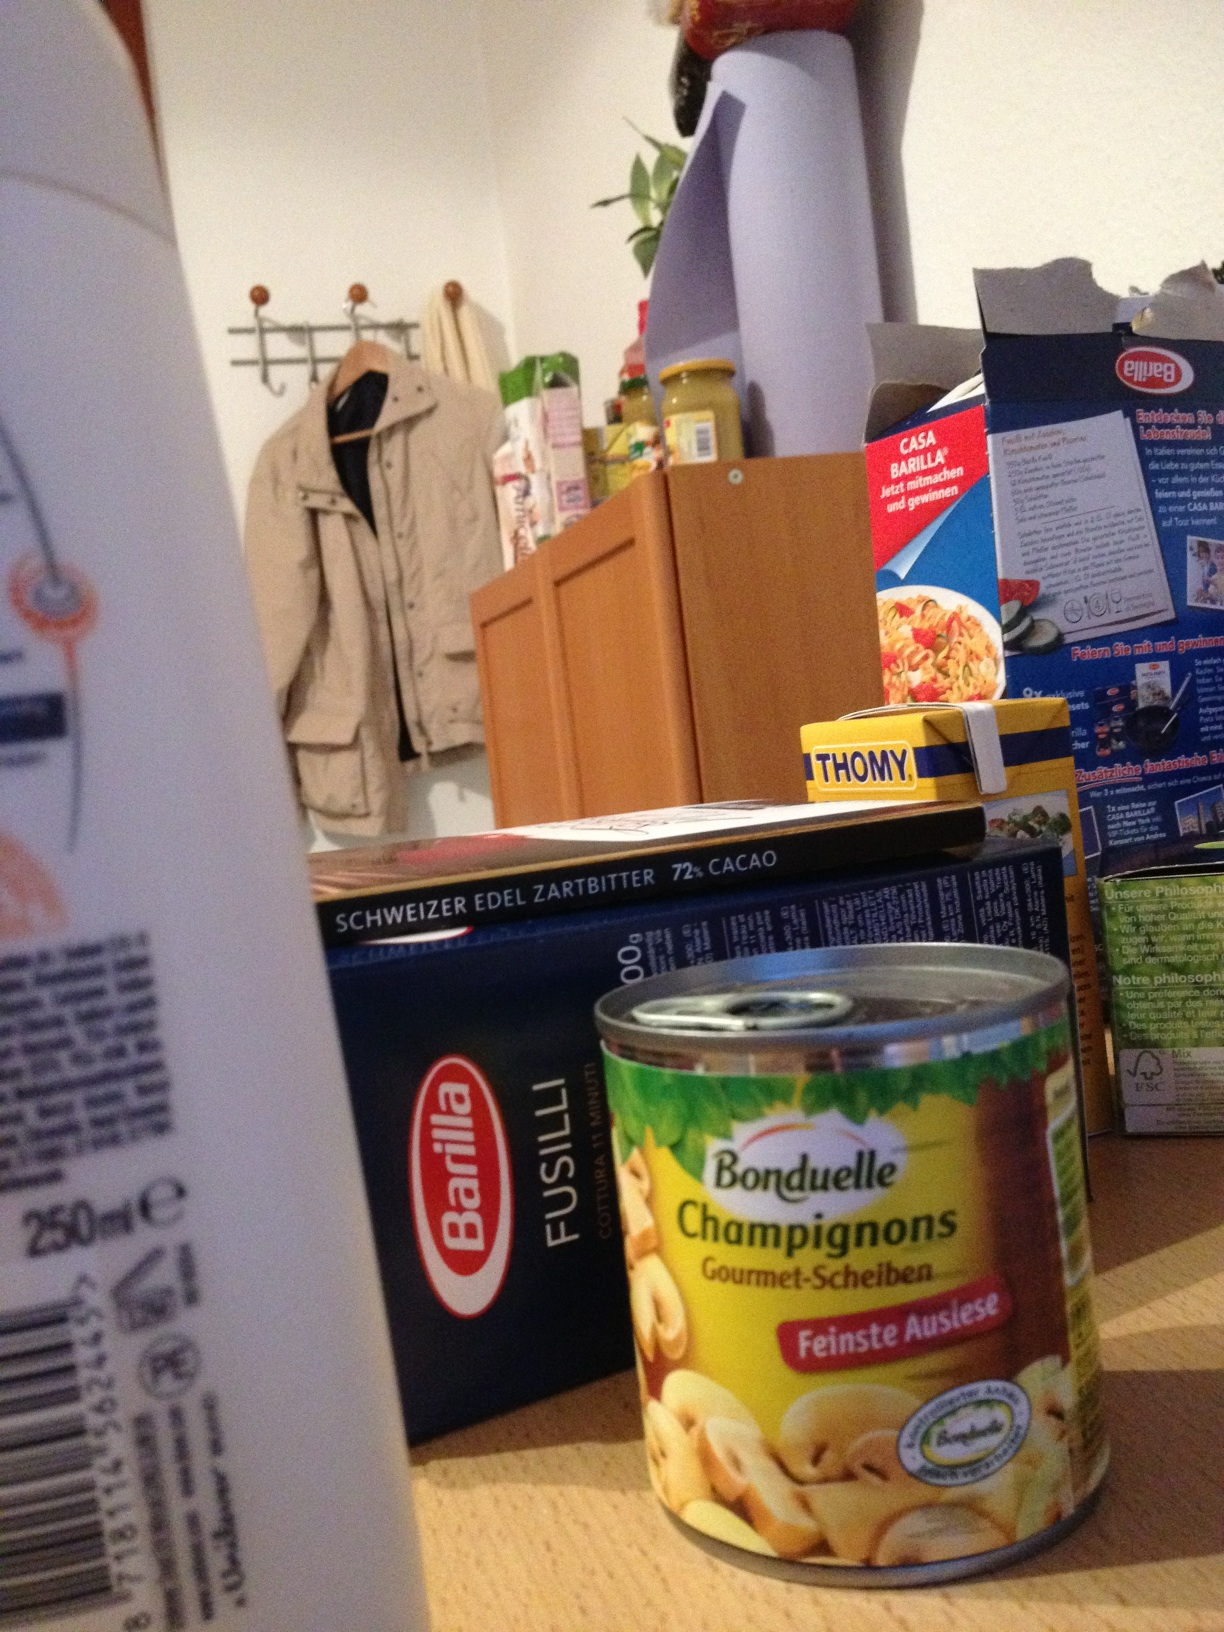Hello. Please tell me the instructions for this shampoo. Thank you. from Vizwiz Unfortunately, I cannot see the instructions on the shampoo bottle clearly due to its position and focus in the image. However, typical shampoo instructions recommend wetting your hair, applying a small amount of shampoo, massaging it gently into your scalp and throughout your hair, then rinsing thoroughly. Be sure to follow any specific instructions if the product is specialized, such as for treated or particular hair types. 